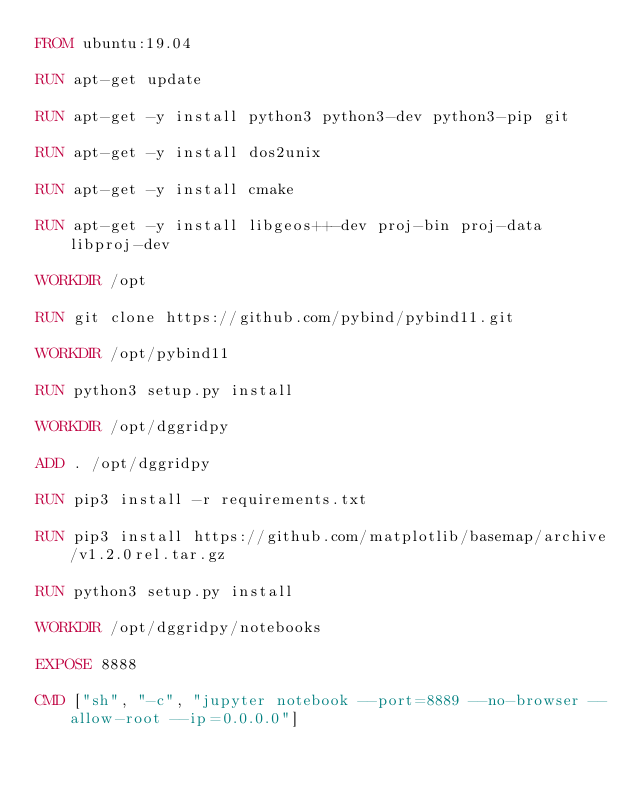Convert code to text. <code><loc_0><loc_0><loc_500><loc_500><_Dockerfile_>FROM ubuntu:19.04

RUN apt-get update

RUN apt-get -y install python3 python3-dev python3-pip git

RUN apt-get -y install dos2unix

RUN apt-get -y install cmake

RUN apt-get -y install libgeos++-dev proj-bin proj-data libproj-dev

WORKDIR /opt

RUN git clone https://github.com/pybind/pybind11.git

WORKDIR /opt/pybind11

RUN python3 setup.py install

WORKDIR /opt/dggridpy

ADD . /opt/dggridpy

RUN pip3 install -r requirements.txt

RUN pip3 install https://github.com/matplotlib/basemap/archive/v1.2.0rel.tar.gz

RUN python3 setup.py install

WORKDIR /opt/dggridpy/notebooks

EXPOSE 8888

CMD ["sh", "-c", "jupyter notebook --port=8889 --no-browser --allow-root --ip=0.0.0.0"]
</code> 